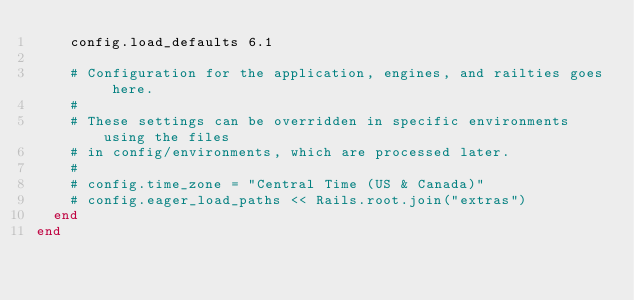Convert code to text. <code><loc_0><loc_0><loc_500><loc_500><_Ruby_>    config.load_defaults 6.1

    # Configuration for the application, engines, and railties goes here.
    #
    # These settings can be overridden in specific environments using the files
    # in config/environments, which are processed later.
    #
    # config.time_zone = "Central Time (US & Canada)"
    # config.eager_load_paths << Rails.root.join("extras")
  end
end
</code> 